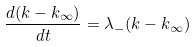Convert formula to latex. <formula><loc_0><loc_0><loc_500><loc_500>\frac { d ( k - k _ { \infty } ) } { d t } = \lambda _ { - } ( k - k _ { \infty } )</formula> 